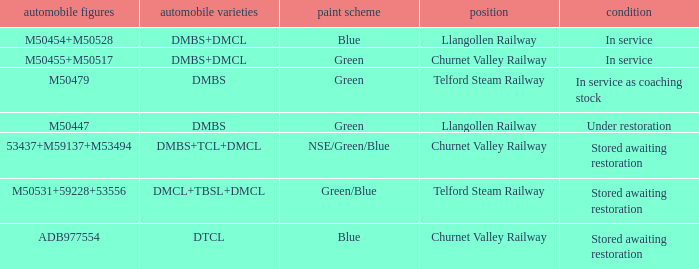What status is the vehicle types of dmbs+tcl+dmcl? Stored awaiting restoration. 